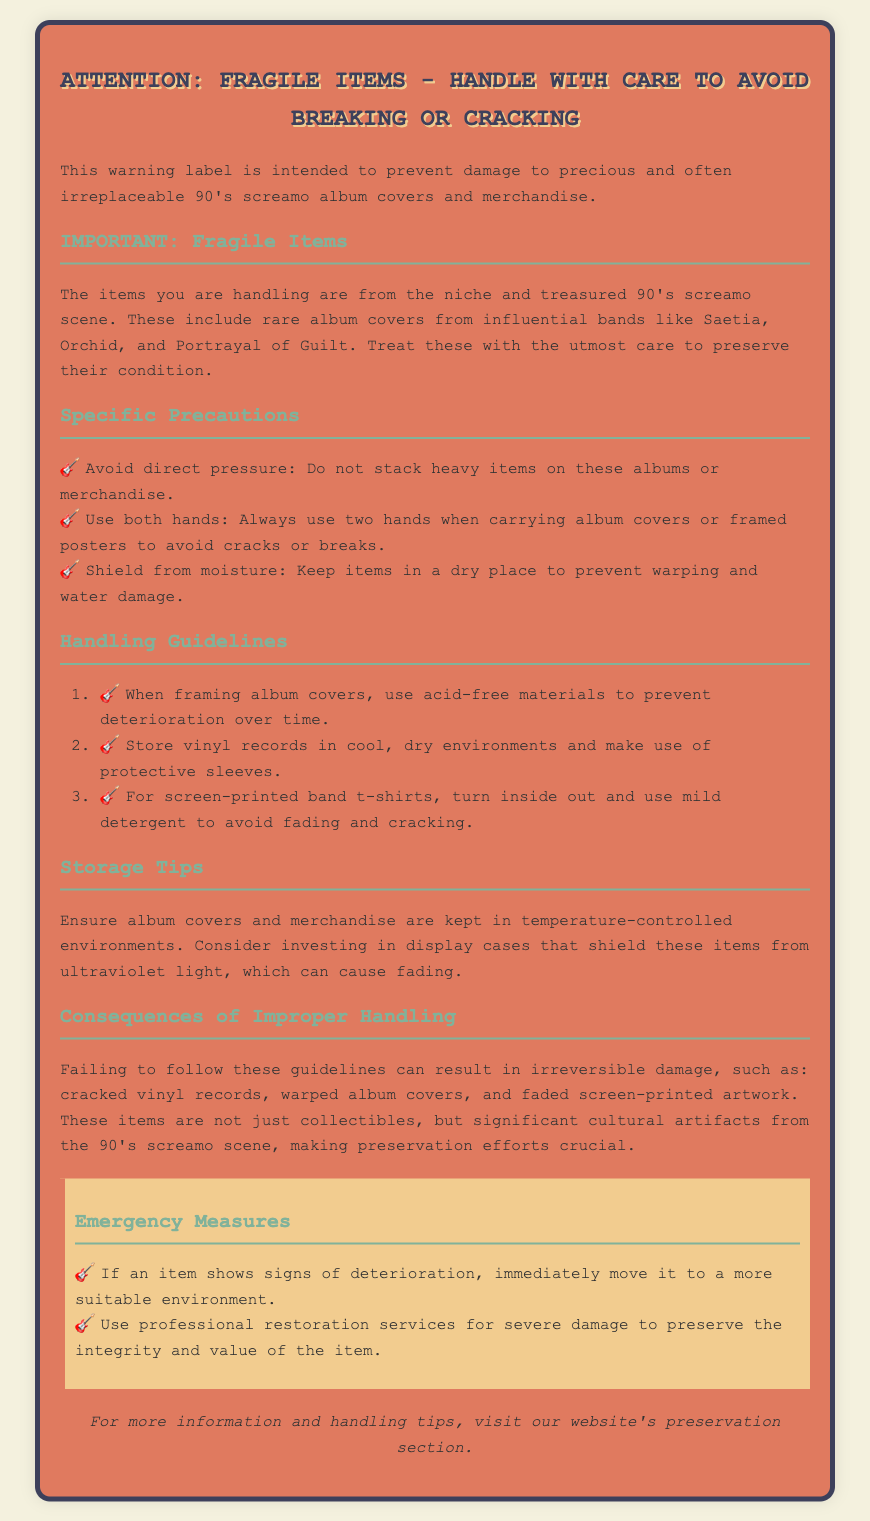What is the main focus of this warning label? The main focus of the warning label is to prevent damage to precious and often irreplaceable 90's screamo album covers and merchandise.
Answer: Prevent damage to precious and often irreplaceable 90's screamo album covers and merchandise Which bands are mentioned in the document? The bands mentioned in the document are influential in the 90's screamo scene. The specific bands are Saetia, Orchid, and Portrayal of Guilt.
Answer: Saetia, Orchid, and Portrayal of Guilt How many specific precautions are listed in the document? The document lists three specific precautions regarding the handling of fragile items.
Answer: Three What should be used for framing album covers? For framing album covers, acid-free materials should be used to prevent deterioration over time.
Answer: Acid-free materials What should you do if an item shows signs of deterioration? If an item shows signs of deterioration, you should immediately move it to a more suitable environment.
Answer: Move it to a more suitable environment Why is preservation of these items crucial? The preservation is crucial because these items are significant cultural artifacts from the 90's screamo scene.
Answer: Significant cultural artifacts from the 90's screamo scene What is the background color of the warning label? The background color of the warning label is a shade of brownish-orange.
Answer: Brownish-orange 